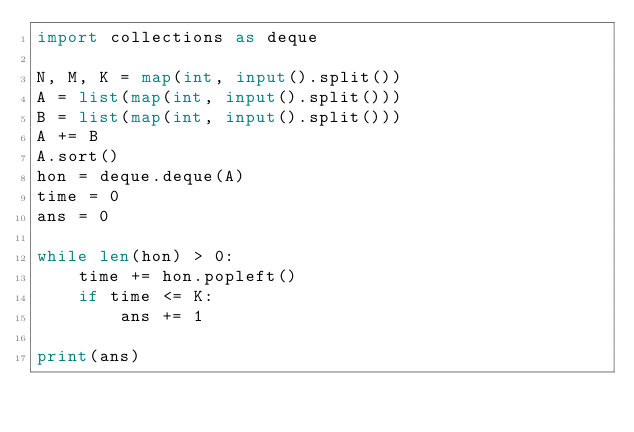<code> <loc_0><loc_0><loc_500><loc_500><_Python_>import collections as deque

N, M, K = map(int, input().split())
A = list(map(int, input().split()))
B = list(map(int, input().split()))
A += B
A.sort()
hon = deque.deque(A)
time = 0
ans = 0

while len(hon) > 0:
    time += hon.popleft()
    if time <= K:
        ans += 1

print(ans)</code> 